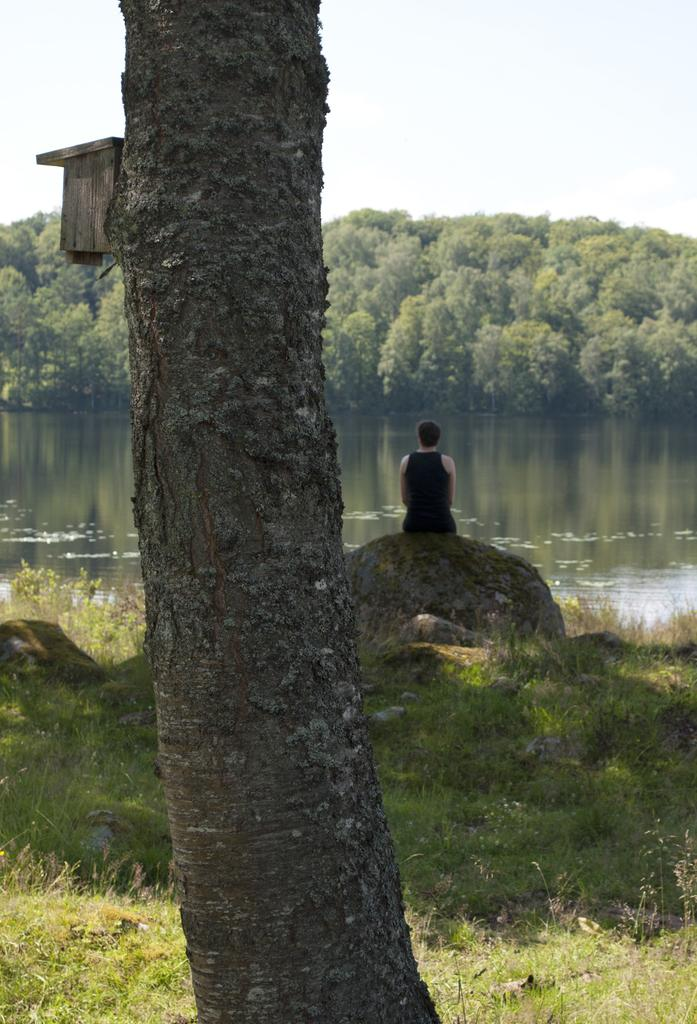What is the main object in the image? There is a tree trunk in the image. What type of vegetation is present in the image? There is grass in the image. What is the person in the image doing? The person is sitting on a rock in the image. What is the person wearing? The person is wearing a black dress. What can be seen in the water in the image? The facts do not specify what can be seen in the water. What is visible in the background of the image? There are trees in the background of the image. What is visible at the top of the image? The sky is visible at the top of the image. What type of statement does the expert make about the cemetery in the image? There is no expert or cemetery present in the image, so it is not possible to answer that question. 